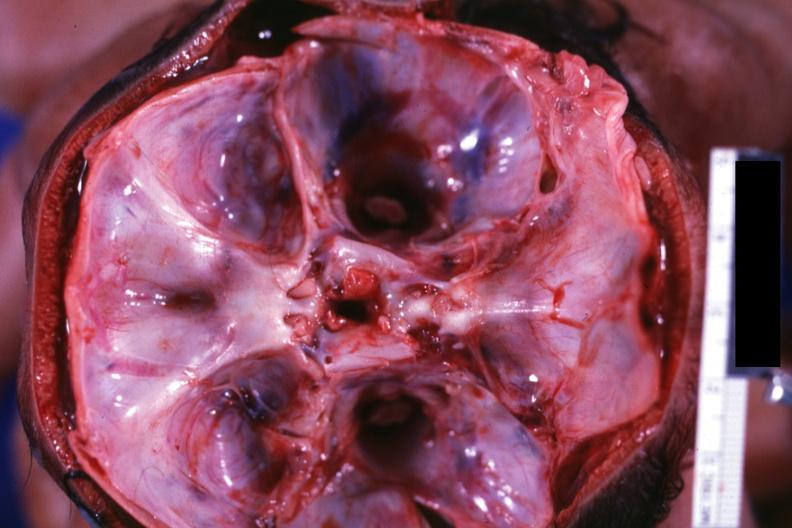s conjoined twins cephalothoracopagus janiceps present?
Answer the question using a single word or phrase. Yes 